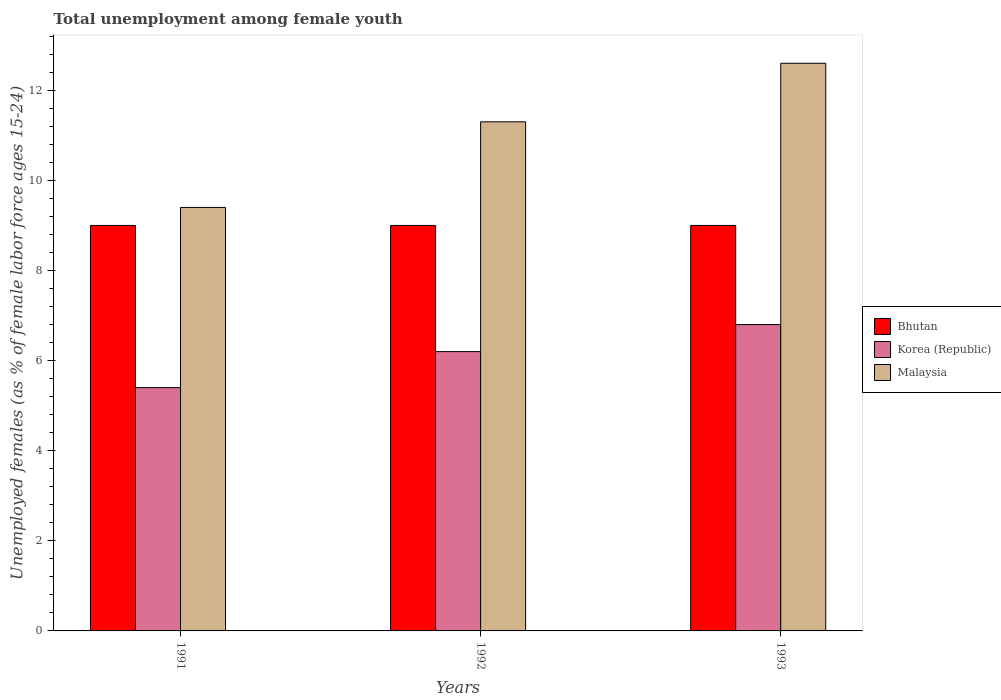Are the number of bars per tick equal to the number of legend labels?
Offer a terse response. Yes. Are the number of bars on each tick of the X-axis equal?
Keep it short and to the point. Yes. How many bars are there on the 1st tick from the left?
Your answer should be compact. 3. How many bars are there on the 1st tick from the right?
Make the answer very short. 3. In how many cases, is the number of bars for a given year not equal to the number of legend labels?
Your response must be concise. 0. What is the percentage of unemployed females in in Malaysia in 1993?
Keep it short and to the point. 12.6. Across all years, what is the maximum percentage of unemployed females in in Korea (Republic)?
Keep it short and to the point. 6.8. Across all years, what is the minimum percentage of unemployed females in in Korea (Republic)?
Keep it short and to the point. 5.4. In which year was the percentage of unemployed females in in Korea (Republic) minimum?
Ensure brevity in your answer.  1991. What is the total percentage of unemployed females in in Korea (Republic) in the graph?
Provide a short and direct response. 18.4. What is the difference between the percentage of unemployed females in in Malaysia in 1991 and that in 1992?
Your response must be concise. -1.9. What is the difference between the percentage of unemployed females in in Bhutan in 1992 and the percentage of unemployed females in in Korea (Republic) in 1993?
Offer a very short reply. 2.2. What is the average percentage of unemployed females in in Korea (Republic) per year?
Give a very brief answer. 6.13. In the year 1992, what is the difference between the percentage of unemployed females in in Bhutan and percentage of unemployed females in in Korea (Republic)?
Give a very brief answer. 2.8. In how many years, is the percentage of unemployed females in in Bhutan greater than 10.8 %?
Give a very brief answer. 0. What is the ratio of the percentage of unemployed females in in Bhutan in 1991 to that in 1992?
Your answer should be compact. 1. Is the percentage of unemployed females in in Bhutan in 1992 less than that in 1993?
Make the answer very short. No. What is the difference between the highest and the second highest percentage of unemployed females in in Korea (Republic)?
Provide a short and direct response. 0.6. What is the difference between the highest and the lowest percentage of unemployed females in in Korea (Republic)?
Provide a short and direct response. 1.4. What does the 2nd bar from the left in 1993 represents?
Your answer should be very brief. Korea (Republic). What does the 3rd bar from the right in 1991 represents?
Your answer should be very brief. Bhutan. Is it the case that in every year, the sum of the percentage of unemployed females in in Malaysia and percentage of unemployed females in in Bhutan is greater than the percentage of unemployed females in in Korea (Republic)?
Provide a short and direct response. Yes. How many years are there in the graph?
Provide a succinct answer. 3. What is the difference between two consecutive major ticks on the Y-axis?
Give a very brief answer. 2. Are the values on the major ticks of Y-axis written in scientific E-notation?
Provide a succinct answer. No. Does the graph contain grids?
Provide a short and direct response. No. How many legend labels are there?
Keep it short and to the point. 3. What is the title of the graph?
Your response must be concise. Total unemployment among female youth. What is the label or title of the X-axis?
Provide a succinct answer. Years. What is the label or title of the Y-axis?
Your answer should be very brief. Unemployed females (as % of female labor force ages 15-24). What is the Unemployed females (as % of female labor force ages 15-24) of Korea (Republic) in 1991?
Your response must be concise. 5.4. What is the Unemployed females (as % of female labor force ages 15-24) of Malaysia in 1991?
Provide a succinct answer. 9.4. What is the Unemployed females (as % of female labor force ages 15-24) in Korea (Republic) in 1992?
Provide a short and direct response. 6.2. What is the Unemployed females (as % of female labor force ages 15-24) in Malaysia in 1992?
Give a very brief answer. 11.3. What is the Unemployed females (as % of female labor force ages 15-24) of Korea (Republic) in 1993?
Your answer should be very brief. 6.8. What is the Unemployed females (as % of female labor force ages 15-24) of Malaysia in 1993?
Keep it short and to the point. 12.6. Across all years, what is the maximum Unemployed females (as % of female labor force ages 15-24) in Bhutan?
Provide a short and direct response. 9. Across all years, what is the maximum Unemployed females (as % of female labor force ages 15-24) of Korea (Republic)?
Your response must be concise. 6.8. Across all years, what is the maximum Unemployed females (as % of female labor force ages 15-24) in Malaysia?
Provide a succinct answer. 12.6. Across all years, what is the minimum Unemployed females (as % of female labor force ages 15-24) in Bhutan?
Your answer should be compact. 9. Across all years, what is the minimum Unemployed females (as % of female labor force ages 15-24) in Korea (Republic)?
Provide a short and direct response. 5.4. Across all years, what is the minimum Unemployed females (as % of female labor force ages 15-24) of Malaysia?
Make the answer very short. 9.4. What is the total Unemployed females (as % of female labor force ages 15-24) of Malaysia in the graph?
Your answer should be very brief. 33.3. What is the difference between the Unemployed females (as % of female labor force ages 15-24) in Malaysia in 1991 and that in 1992?
Keep it short and to the point. -1.9. What is the difference between the Unemployed females (as % of female labor force ages 15-24) of Bhutan in 1991 and that in 1993?
Provide a short and direct response. 0. What is the difference between the Unemployed females (as % of female labor force ages 15-24) of Korea (Republic) in 1991 and that in 1993?
Provide a succinct answer. -1.4. What is the difference between the Unemployed females (as % of female labor force ages 15-24) of Malaysia in 1991 and that in 1993?
Give a very brief answer. -3.2. What is the difference between the Unemployed females (as % of female labor force ages 15-24) in Korea (Republic) in 1992 and that in 1993?
Your response must be concise. -0.6. What is the difference between the Unemployed females (as % of female labor force ages 15-24) of Bhutan in 1991 and the Unemployed females (as % of female labor force ages 15-24) of Korea (Republic) in 1993?
Offer a very short reply. 2.2. What is the difference between the Unemployed females (as % of female labor force ages 15-24) of Bhutan in 1991 and the Unemployed females (as % of female labor force ages 15-24) of Malaysia in 1993?
Keep it short and to the point. -3.6. What is the difference between the Unemployed females (as % of female labor force ages 15-24) of Korea (Republic) in 1992 and the Unemployed females (as % of female labor force ages 15-24) of Malaysia in 1993?
Ensure brevity in your answer.  -6.4. What is the average Unemployed females (as % of female labor force ages 15-24) of Korea (Republic) per year?
Offer a very short reply. 6.13. In the year 1991, what is the difference between the Unemployed females (as % of female labor force ages 15-24) in Korea (Republic) and Unemployed females (as % of female labor force ages 15-24) in Malaysia?
Provide a succinct answer. -4. In the year 1992, what is the difference between the Unemployed females (as % of female labor force ages 15-24) in Bhutan and Unemployed females (as % of female labor force ages 15-24) in Korea (Republic)?
Give a very brief answer. 2.8. In the year 1992, what is the difference between the Unemployed females (as % of female labor force ages 15-24) in Korea (Republic) and Unemployed females (as % of female labor force ages 15-24) in Malaysia?
Your answer should be very brief. -5.1. What is the ratio of the Unemployed females (as % of female labor force ages 15-24) in Bhutan in 1991 to that in 1992?
Ensure brevity in your answer.  1. What is the ratio of the Unemployed females (as % of female labor force ages 15-24) of Korea (Republic) in 1991 to that in 1992?
Provide a short and direct response. 0.87. What is the ratio of the Unemployed females (as % of female labor force ages 15-24) of Malaysia in 1991 to that in 1992?
Your response must be concise. 0.83. What is the ratio of the Unemployed females (as % of female labor force ages 15-24) in Korea (Republic) in 1991 to that in 1993?
Your answer should be compact. 0.79. What is the ratio of the Unemployed females (as % of female labor force ages 15-24) in Malaysia in 1991 to that in 1993?
Provide a succinct answer. 0.75. What is the ratio of the Unemployed females (as % of female labor force ages 15-24) of Korea (Republic) in 1992 to that in 1993?
Offer a terse response. 0.91. What is the ratio of the Unemployed females (as % of female labor force ages 15-24) in Malaysia in 1992 to that in 1993?
Your response must be concise. 0.9. What is the difference between the highest and the second highest Unemployed females (as % of female labor force ages 15-24) in Bhutan?
Provide a short and direct response. 0. What is the difference between the highest and the second highest Unemployed females (as % of female labor force ages 15-24) in Malaysia?
Provide a succinct answer. 1.3. What is the difference between the highest and the lowest Unemployed females (as % of female labor force ages 15-24) of Bhutan?
Offer a terse response. 0. 